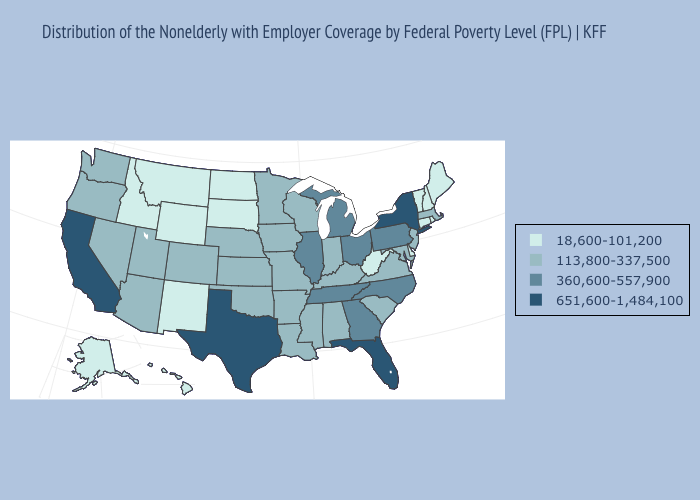Does California have the highest value in the West?
Concise answer only. Yes. Does Alabama have a higher value than Tennessee?
Concise answer only. No. Does New York have the highest value in the USA?
Quick response, please. Yes. What is the value of New York?
Short answer required. 651,600-1,484,100. Which states have the lowest value in the USA?
Keep it brief. Alaska, Connecticut, Delaware, Hawaii, Idaho, Maine, Montana, New Hampshire, New Mexico, North Dakota, Rhode Island, South Dakota, Vermont, West Virginia, Wyoming. What is the value of Oklahoma?
Give a very brief answer. 113,800-337,500. What is the value of Nebraska?
Quick response, please. 113,800-337,500. What is the value of Nebraska?
Quick response, please. 113,800-337,500. Which states have the highest value in the USA?
Answer briefly. California, Florida, New York, Texas. Among the states that border North Dakota , does South Dakota have the lowest value?
Be succinct. Yes. What is the value of Florida?
Be succinct. 651,600-1,484,100. Among the states that border Georgia , which have the lowest value?
Answer briefly. Alabama, South Carolina. What is the value of West Virginia?
Concise answer only. 18,600-101,200. What is the value of Indiana?
Concise answer only. 113,800-337,500. What is the highest value in the Northeast ?
Give a very brief answer. 651,600-1,484,100. 